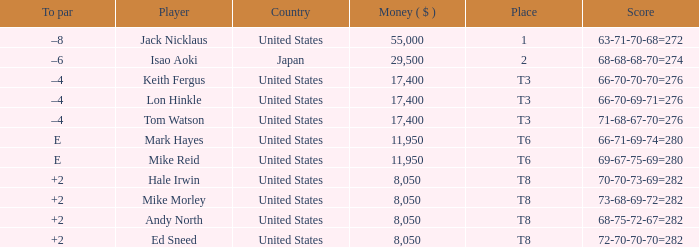What country has the score og 66-70-69-71=276? United States. 